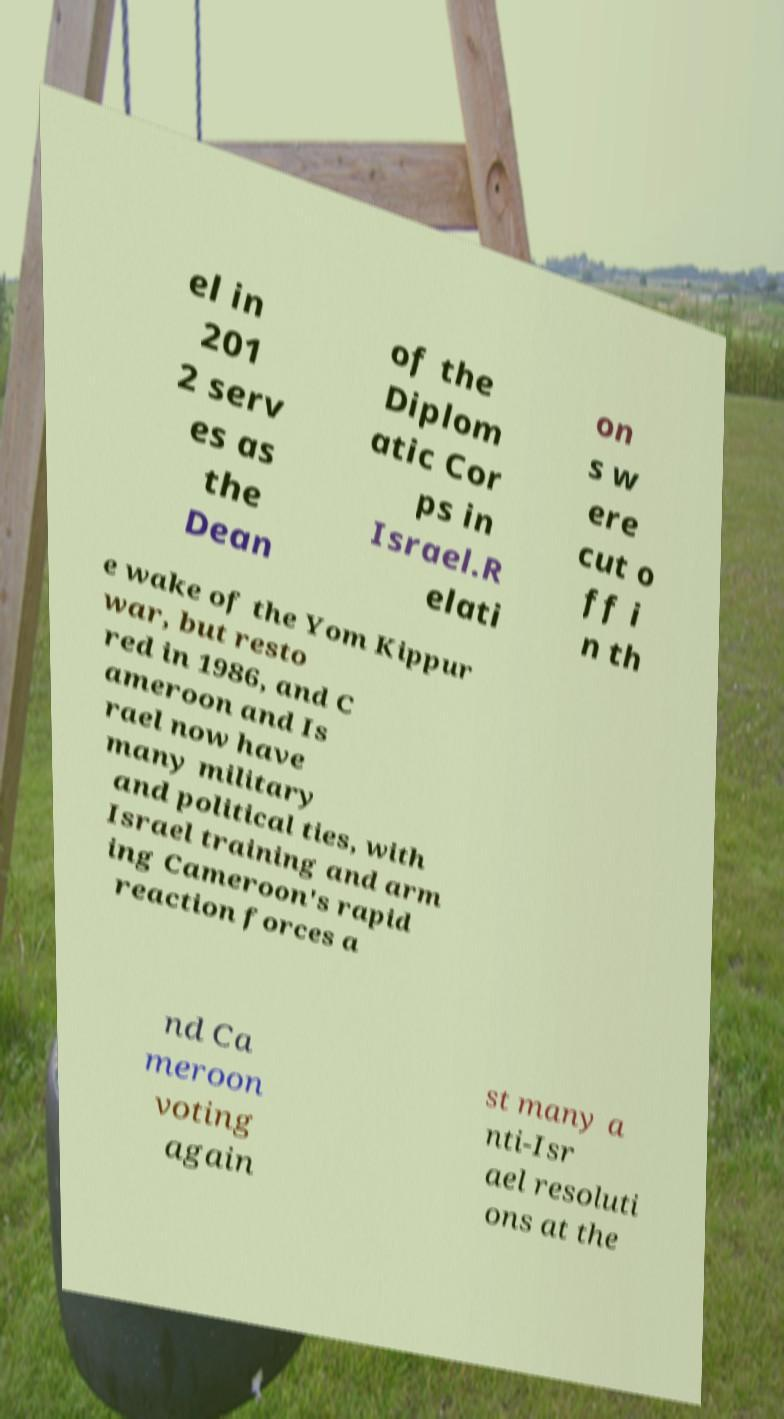There's text embedded in this image that I need extracted. Can you transcribe it verbatim? el in 201 2 serv es as the Dean of the Diplom atic Cor ps in Israel.R elati on s w ere cut o ff i n th e wake of the Yom Kippur war, but resto red in 1986, and C ameroon and Is rael now have many military and political ties, with Israel training and arm ing Cameroon's rapid reaction forces a nd Ca meroon voting again st many a nti-Isr ael resoluti ons at the 